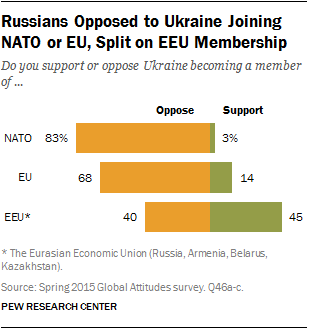Highlight a few significant elements in this photo. The sum of all the support bars in the graph is 62. The two bars represent support and opposition to a particular idea or proposal. 